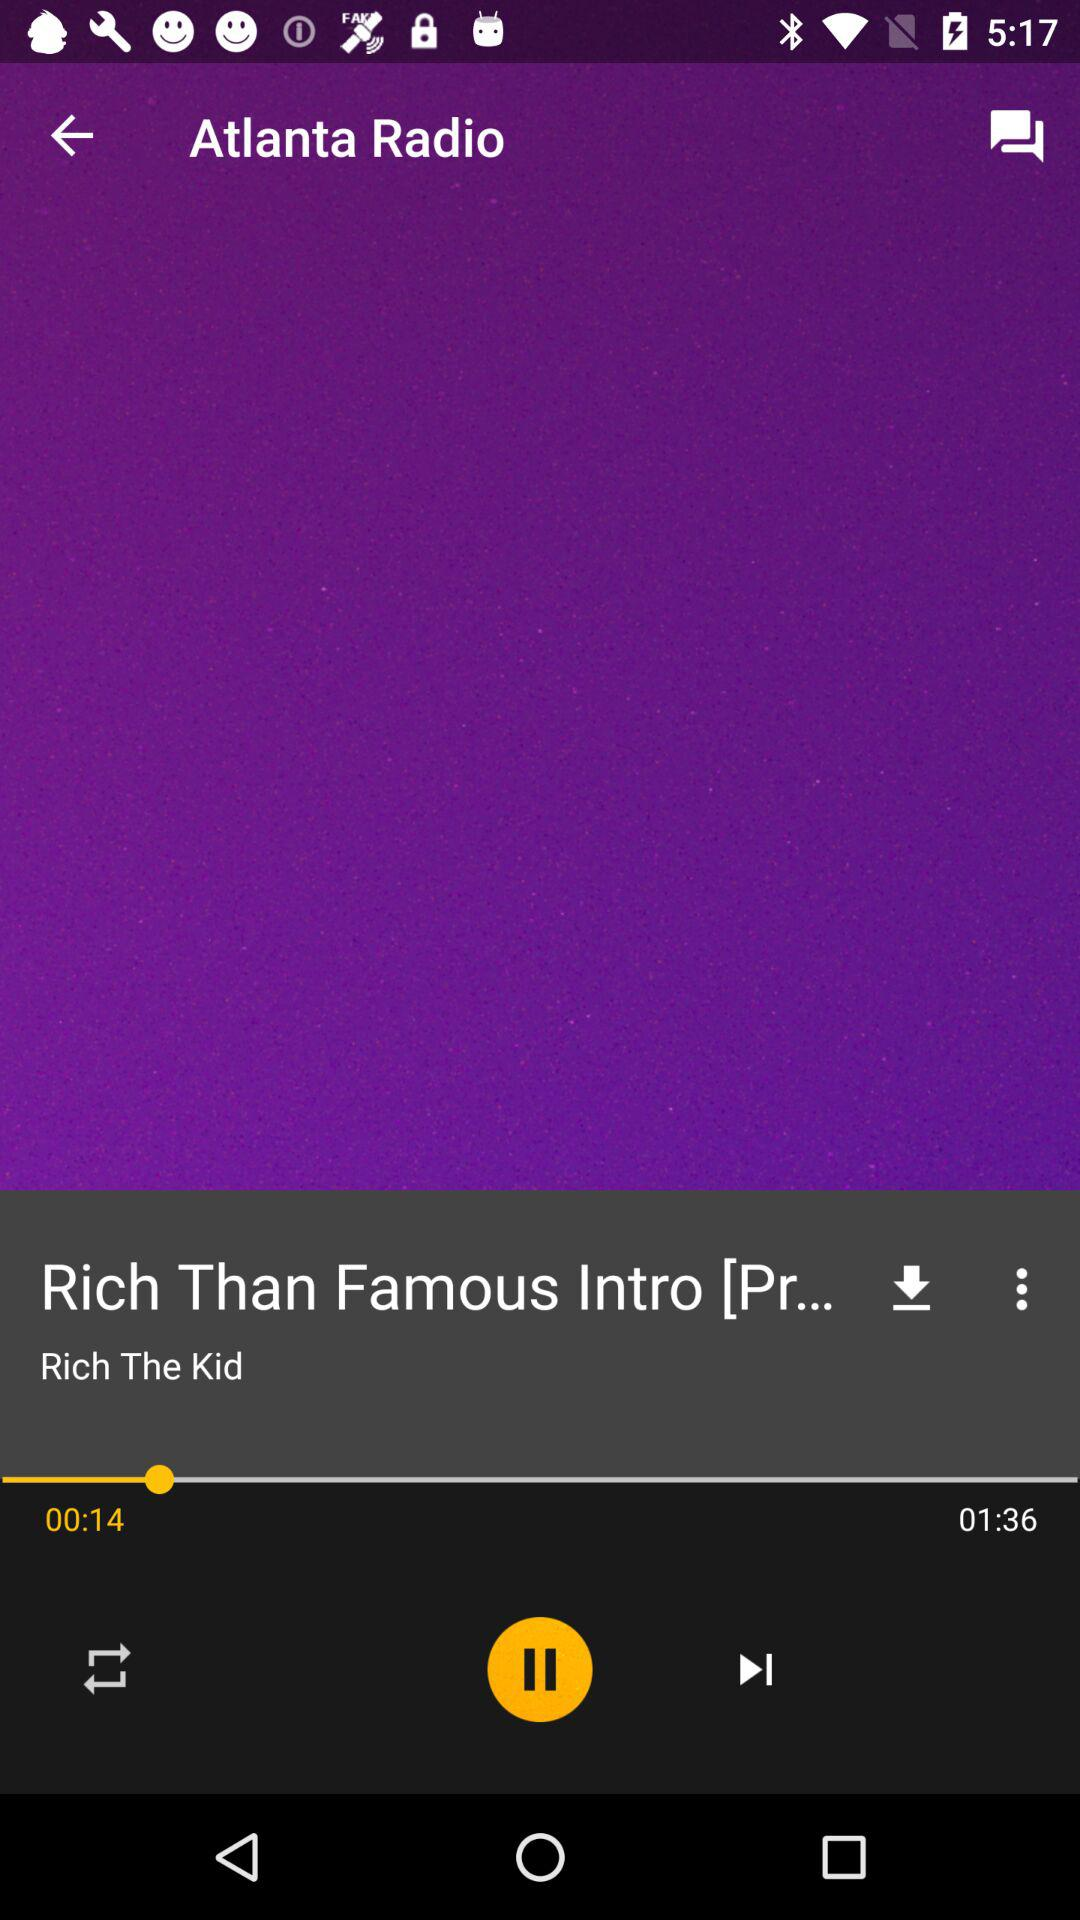What's the duration of the song "Rich Than Famous"? The duration of the song is 1 minute and 36 seconds. 